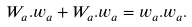<formula> <loc_0><loc_0><loc_500><loc_500>{ W _ { a } . w _ { a } } + { W _ { a } . w _ { a } } = { w _ { a } . w _ { a } } .</formula> 